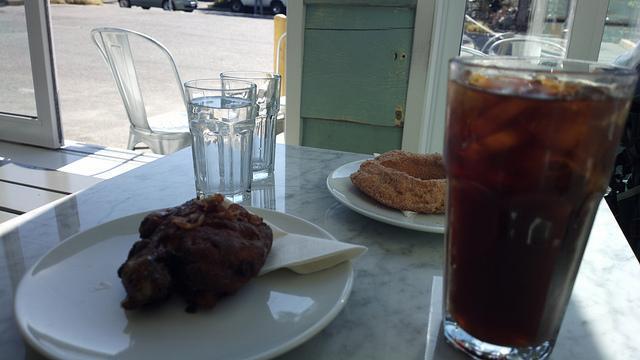How many chairs are visible?
Give a very brief answer. 2. How many cups are there?
Give a very brief answer. 3. 